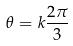<formula> <loc_0><loc_0><loc_500><loc_500>\theta = k \frac { 2 \pi } { 3 }</formula> 